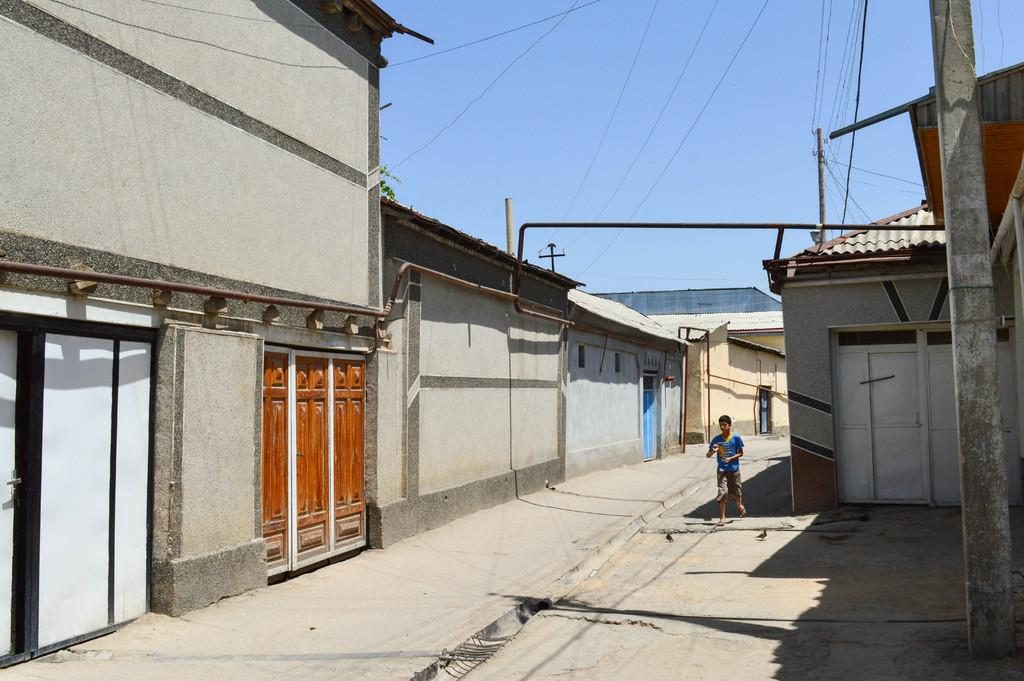What type of structures can be seen in the image? There are buildings in the image. What else can be seen in the image besides the buildings? There are poles and wires in the image. What is the person in the image doing? There is a person running in the center of the image. Can you tell me how many mittens are being worn by the person running in the image? There are no mittens present in the image; the person is running without any gloves or mittens. What type of error is being corrected by the person running in the image? There is no indication of an error or correction in the image; the person is simply running. 